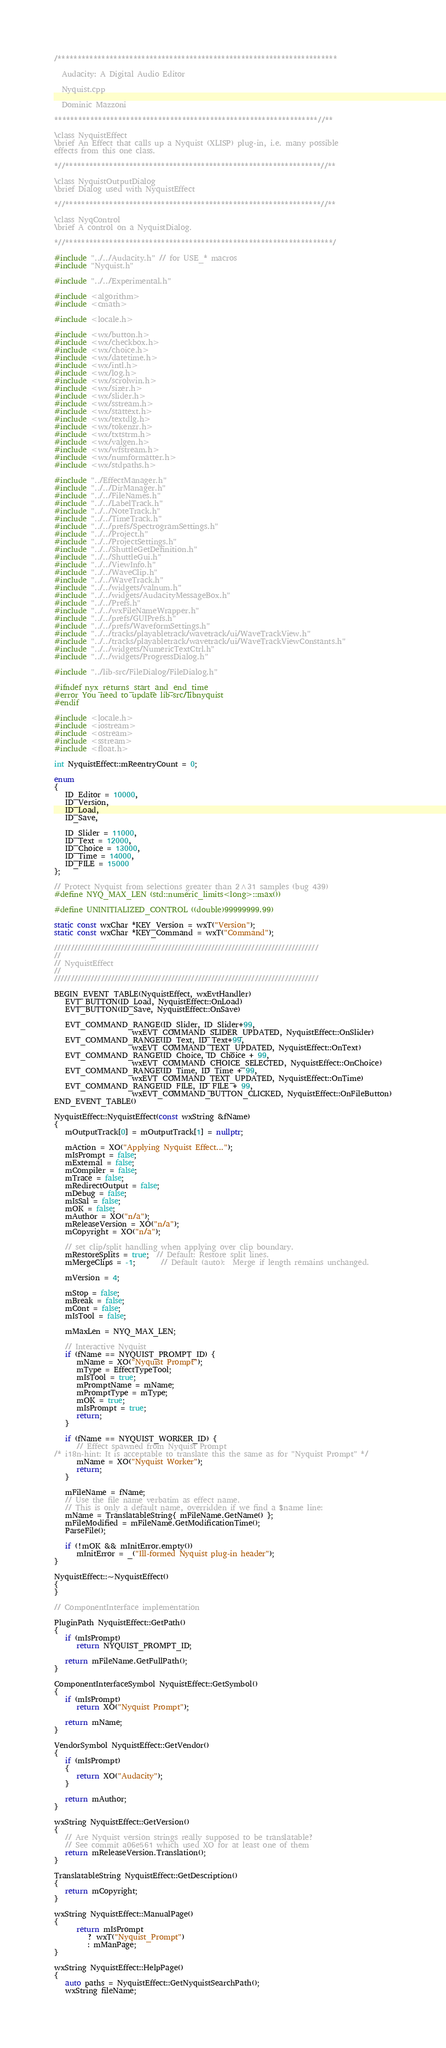<code> <loc_0><loc_0><loc_500><loc_500><_C++_>/**********************************************************************

  Audacity: A Digital Audio Editor

  Nyquist.cpp

  Dominic Mazzoni

******************************************************************//**

\class NyquistEffect
\brief An Effect that calls up a Nyquist (XLISP) plug-in, i.e. many possible
effects from this one class.

*//****************************************************************//**

\class NyquistOutputDialog
\brief Dialog used with NyquistEffect

*//****************************************************************//**

\class NyqControl
\brief A control on a NyquistDialog.

*//*******************************************************************/

#include "../../Audacity.h" // for USE_* macros
#include "Nyquist.h"

#include "../../Experimental.h"

#include <algorithm>
#include <cmath>

#include <locale.h>

#include <wx/button.h>
#include <wx/checkbox.h>
#include <wx/choice.h>
#include <wx/datetime.h>
#include <wx/intl.h>
#include <wx/log.h>
#include <wx/scrolwin.h>
#include <wx/sizer.h>
#include <wx/slider.h>
#include <wx/sstream.h>
#include <wx/stattext.h>
#include <wx/textdlg.h>
#include <wx/tokenzr.h>
#include <wx/txtstrm.h>
#include <wx/valgen.h>
#include <wx/wfstream.h>
#include <wx/numformatter.h>
#include <wx/stdpaths.h>

#include "../EffectManager.h"
#include "../../DirManager.h"
#include "../../FileNames.h"
#include "../../LabelTrack.h"
#include "../../NoteTrack.h"
#include "../../TimeTrack.h"
#include "../../prefs/SpectrogramSettings.h"
#include "../../Project.h"
#include "../../ProjectSettings.h"
#include "../../ShuttleGetDefinition.h"
#include "../../ShuttleGui.h"
#include "../../ViewInfo.h"
#include "../../WaveClip.h"
#include "../../WaveTrack.h"
#include "../../widgets/valnum.h"
#include "../../widgets/AudacityMessageBox.h"
#include "../../Prefs.h"
#include "../../wxFileNameWrapper.h"
#include "../../prefs/GUIPrefs.h"
#include "../../prefs/WaveformSettings.h"
#include "../../tracks/playabletrack/wavetrack/ui/WaveTrackView.h"
#include "../../tracks/playabletrack/wavetrack/ui/WaveTrackViewConstants.h"
#include "../../widgets/NumericTextCtrl.h"
#include "../../widgets/ProgressDialog.h"

#include "../lib-src/FileDialog/FileDialog.h"

#ifndef nyx_returns_start_and_end_time
#error You need to update lib-src/libnyquist
#endif

#include <locale.h>
#include <iostream>
#include <ostream>
#include <sstream>
#include <float.h>

int NyquistEffect::mReentryCount = 0;

enum
{
   ID_Editor = 10000,
   ID_Version,
   ID_Load,
   ID_Save,

   ID_Slider = 11000,
   ID_Text = 12000,
   ID_Choice = 13000,
   ID_Time = 14000,
   ID_FILE = 15000
};

// Protect Nyquist from selections greater than 2^31 samples (bug 439)
#define NYQ_MAX_LEN (std::numeric_limits<long>::max())

#define UNINITIALIZED_CONTROL ((double)99999999.99)

static const wxChar *KEY_Version = wxT("Version");
static const wxChar *KEY_Command = wxT("Command");

///////////////////////////////////////////////////////////////////////////////
//
// NyquistEffect
//
///////////////////////////////////////////////////////////////////////////////

BEGIN_EVENT_TABLE(NyquistEffect, wxEvtHandler)
   EVT_BUTTON(ID_Load, NyquistEffect::OnLoad)
   EVT_BUTTON(ID_Save, NyquistEffect::OnSave)

   EVT_COMMAND_RANGE(ID_Slider, ID_Slider+99,
                     wxEVT_COMMAND_SLIDER_UPDATED, NyquistEffect::OnSlider)
   EVT_COMMAND_RANGE(ID_Text, ID_Text+99,
                     wxEVT_COMMAND_TEXT_UPDATED, NyquistEffect::OnText)
   EVT_COMMAND_RANGE(ID_Choice, ID_Choice + 99,
                     wxEVT_COMMAND_CHOICE_SELECTED, NyquistEffect::OnChoice)
   EVT_COMMAND_RANGE(ID_Time, ID_Time + 99,
                     wxEVT_COMMAND_TEXT_UPDATED, NyquistEffect::OnTime)
   EVT_COMMAND_RANGE(ID_FILE, ID_FILE + 99,
                     wxEVT_COMMAND_BUTTON_CLICKED, NyquistEffect::OnFileButton)
END_EVENT_TABLE()

NyquistEffect::NyquistEffect(const wxString &fName)
{
   mOutputTrack[0] = mOutputTrack[1] = nullptr;

   mAction = XO("Applying Nyquist Effect...");
   mIsPrompt = false;
   mExternal = false;
   mCompiler = false;
   mTrace = false;
   mRedirectOutput = false;
   mDebug = false;
   mIsSal = false;
   mOK = false;
   mAuthor = XO("n/a");
   mReleaseVersion = XO("n/a");
   mCopyright = XO("n/a");

   // set clip/split handling when applying over clip boundary.
   mRestoreSplits = true;  // Default: Restore split lines.
   mMergeClips = -1;       // Default (auto):  Merge if length remains unchanged.

   mVersion = 4;

   mStop = false;
   mBreak = false;
   mCont = false;
   mIsTool = false;

   mMaxLen = NYQ_MAX_LEN;

   // Interactive Nyquist
   if (fName == NYQUIST_PROMPT_ID) {
      mName = XO("Nyquist Prompt");
      mType = EffectTypeTool;
      mIsTool = true;
      mPromptName = mName;
      mPromptType = mType;
      mOK = true;
      mIsPrompt = true;
      return;
   }

   if (fName == NYQUIST_WORKER_ID) {
      // Effect spawned from Nyquist Prompt
/* i18n-hint: It is acceptable to translate this the same as for "Nyquist Prompt" */
      mName = XO("Nyquist Worker");
      return;
   }

   mFileName = fName;
   // Use the file name verbatim as effect name.
   // This is only a default name, overridden if we find a $name line:
   mName = TranslatableString{ mFileName.GetName() };
   mFileModified = mFileName.GetModificationTime();
   ParseFile();

   if (!mOK && mInitError.empty())
      mInitError = _("Ill-formed Nyquist plug-in header");
}

NyquistEffect::~NyquistEffect()
{
}

// ComponentInterface implementation

PluginPath NyquistEffect::GetPath()
{
   if (mIsPrompt)
      return NYQUIST_PROMPT_ID;

   return mFileName.GetFullPath();
}

ComponentInterfaceSymbol NyquistEffect::GetSymbol()
{
   if (mIsPrompt)
      return XO("Nyquist Prompt");

   return mName;
}

VendorSymbol NyquistEffect::GetVendor()
{
   if (mIsPrompt)
   {
      return XO("Audacity");
   }

   return mAuthor;
}

wxString NyquistEffect::GetVersion()
{
   // Are Nyquist version strings really supposed to be translatable?
   // See commit a06e561 which used XO for at least one of them
   return mReleaseVersion.Translation();
}

TranslatableString NyquistEffect::GetDescription()
{
   return mCopyright;
}

wxString NyquistEffect::ManualPage()
{
      return mIsPrompt
         ? wxT("Nyquist_Prompt")
         : mManPage;
}

wxString NyquistEffect::HelpPage()
{
   auto paths = NyquistEffect::GetNyquistSearchPath();
   wxString fileName;
</code> 